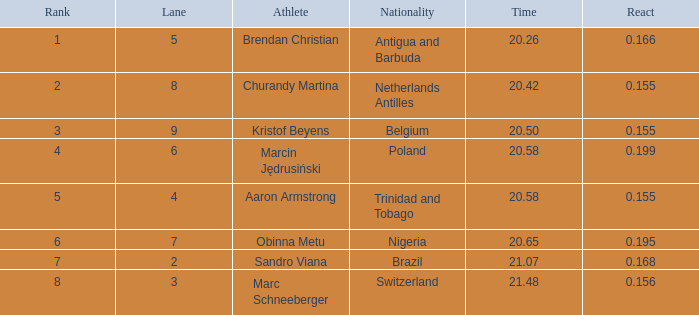How much Time has a Reaction of 0.155, and an Athlete of kristof beyens, and a Rank smaller than 3? 0.0. 